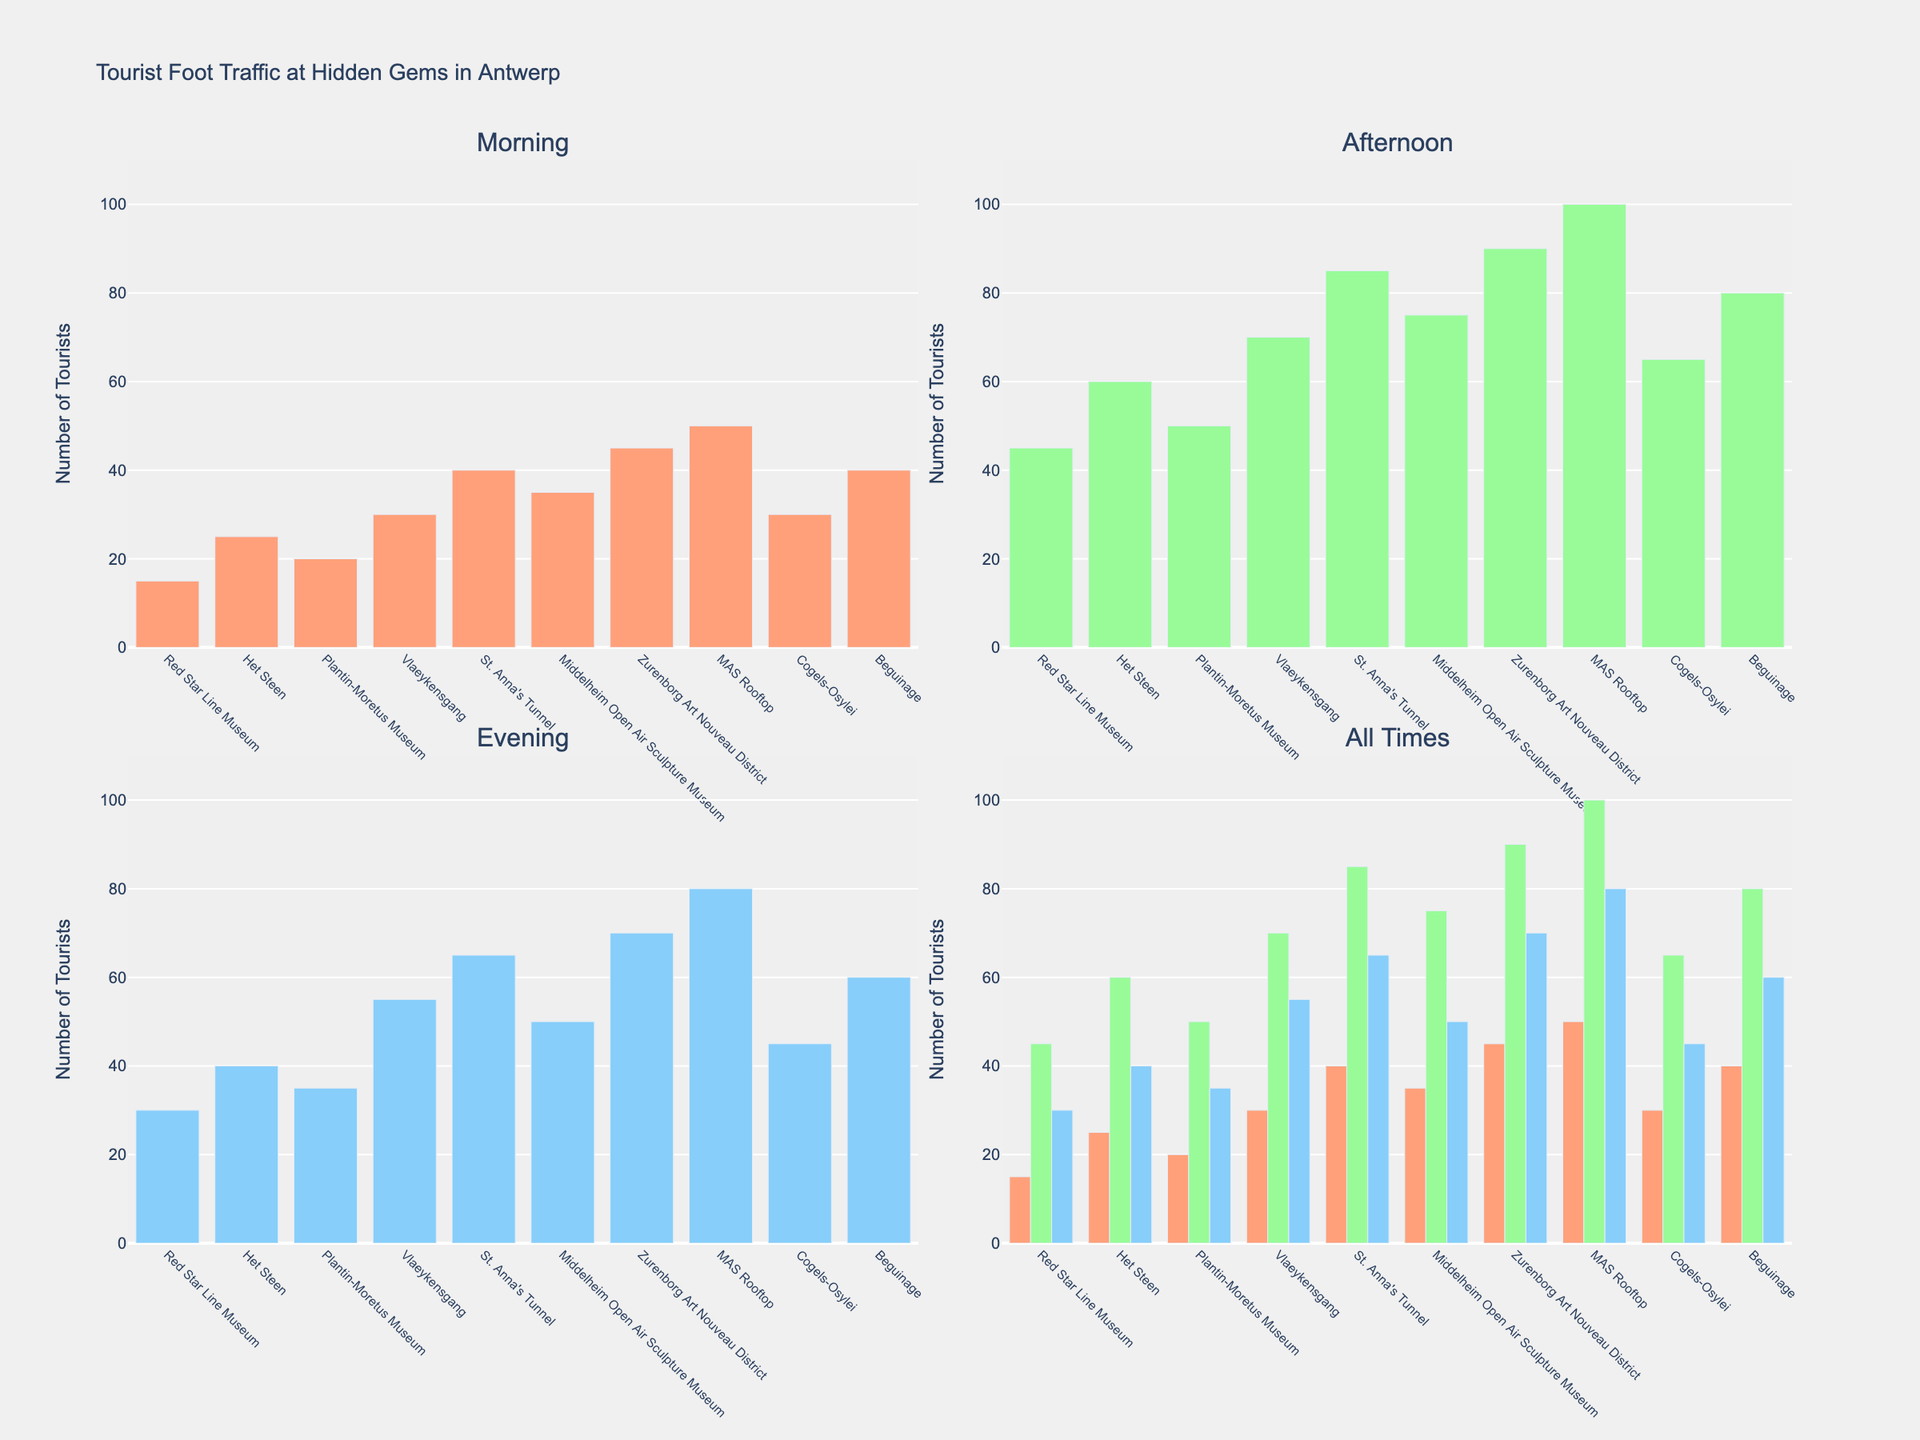Which hidden gem has the highest tourist foot traffic in the morning? To find the answer, look at the subplot representing the 'Morning' time and identify the highest bar. "MAS Rooftop" has the highest bar.
Answer: MAS Rooftop Which location sees the most tourists in the evening? To answer, look at the subplot for 'Evening' and identify the highest bar, which represents "MAS Rooftop".
Answer: MAS Rooftop How many tourists visit Vlaeykensgang in the afternoon? By referring to the 'Afternoon' subplot, locate the bar corresponding to "Vlaeykensgang" and check its height.
Answer: 70 What is the total tourist foot traffic for St. Anna's Tunnel throughout the day? Summing the values for "Morning" (40), "Afternoon" (85), and "Evening" (65), the total is 40 + 85 + 65.
Answer: 190 Which location has the least tourists in the afternoon? In the 'Afternoon' subplot, identify the shortest bar. It corresponds to "Red Star Line Museum".
Answer: Red Star Line Museum How does the foot traffic at Het Steen compare between morning and evening? In the subplots, compare the values for Het Steen in 'Morning' (25) and 'Evening' (40). The evening count is higher.
Answer: Evening is higher What is the average number of tourists in the morning across all locations? Sum the tourist numbers for all locations in the morning (15+25+20+30+40+35+45+50+30+40 = 330), then divide by the number of locations (10).
Answer: 33 Identify the location with the most balanced foot traffic across all times of the day. Balance can be assessed by comparing the differences in tourist numbers across times. "Red Star Line Museum" has relatively close numbers (15, 45, 30), indicating balance.
Answer: Red Star Line Museum Which location experiences the largest increase in tourist numbers from morning to afternoon? To find the largest increase, calculate the difference between morning and afternoon for each location and compare. The largest increase is for "St. Anna's Tunnel" (85 - 40 = 45).
Answer: St. Anna's Tunnel Compare the total foot traffic of Plantin-Moretus Museum and Beguinage throughout the day. Sum "Morning", "Afternoon", and "Evening" values for both locations and compare: Plantin-Moretus Museum (20+50+35=105) and Beguinage (40+80+60=180). Beguinage has higher total traffic.
Answer: Beguinage 